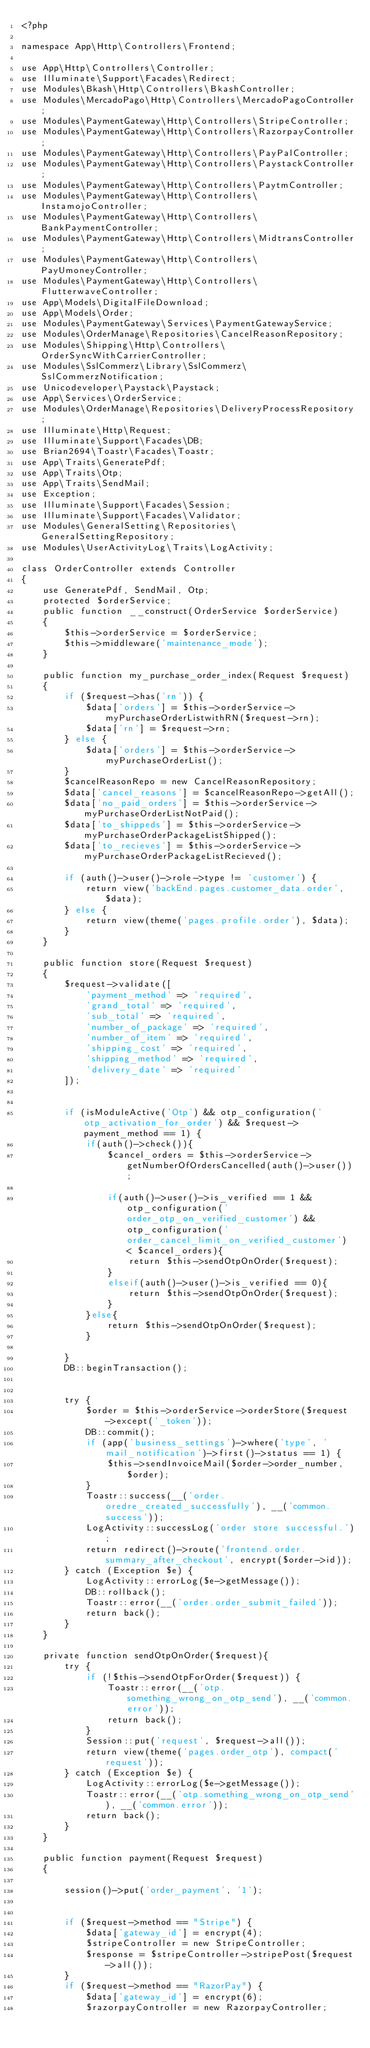<code> <loc_0><loc_0><loc_500><loc_500><_PHP_><?php

namespace App\Http\Controllers\Frontend;

use App\Http\Controllers\Controller;
use Illuminate\Support\Facades\Redirect;
use Modules\Bkash\Http\Controllers\BkashController;
use Modules\MercadoPago\Http\Controllers\MercadoPagoController;
use Modules\PaymentGateway\Http\Controllers\StripeController;
use Modules\PaymentGateway\Http\Controllers\RazorpayController;
use Modules\PaymentGateway\Http\Controllers\PayPalController;
use Modules\PaymentGateway\Http\Controllers\PaystackController;
use Modules\PaymentGateway\Http\Controllers\PaytmController;
use Modules\PaymentGateway\Http\Controllers\InstamojoController;
use Modules\PaymentGateway\Http\Controllers\BankPaymentController;
use Modules\PaymentGateway\Http\Controllers\MidtransController;
use Modules\PaymentGateway\Http\Controllers\PayUmoneyController;
use Modules\PaymentGateway\Http\Controllers\FlutterwaveController;
use App\Models\DigitalFileDownload;
use App\Models\Order;
use Modules\PaymentGateway\Services\PaymentGatewayService;
use Modules\OrderManage\Repositories\CancelReasonRepository;
use Modules\Shipping\Http\Controllers\OrderSyncWithCarrierController;
use Modules\SslCommerz\Library\SslCommerz\SslCommerzNotification;
use Unicodeveloper\Paystack\Paystack;
use App\Services\OrderService;
use Modules\OrderManage\Repositories\DeliveryProcessRepository;
use Illuminate\Http\Request;
use Illuminate\Support\Facades\DB;
use Brian2694\Toastr\Facades\Toastr;
use App\Traits\GeneratePdf;
use App\Traits\Otp;
use App\Traits\SendMail;
use Exception;
use Illuminate\Support\Facades\Session;
use Illuminate\Support\Facades\Validator;
use Modules\GeneralSetting\Repositories\GeneralSettingRepository;
use Modules\UserActivityLog\Traits\LogActivity;

class OrderController extends Controller
{
    use GeneratePdf, SendMail, Otp;
    protected $orderService;
    public function __construct(OrderService $orderService)
    {
        $this->orderService = $orderService;
        $this->middleware('maintenance_mode');
    }

    public function my_purchase_order_index(Request $request)
    {
        if ($request->has('rn')) {
            $data['orders'] = $this->orderService->myPurchaseOrderListwithRN($request->rn);
            $data['rn'] = $request->rn;
        } else {
            $data['orders'] = $this->orderService->myPurchaseOrderList();
        }
        $cancelReasonRepo = new CancelReasonRepository;
        $data['cancel_reasons'] = $cancelReasonRepo->getAll();
        $data['no_paid_orders'] = $this->orderService->myPurchaseOrderListNotPaid();
        $data['to_shippeds'] = $this->orderService->myPurchaseOrderPackageListShipped();
        $data['to_recieves'] = $this->orderService->myPurchaseOrderPackageListRecieved();

        if (auth()->user()->role->type != 'customer') {
            return view('backEnd.pages.customer_data.order', $data);
        } else {
            return view(theme('pages.profile.order'), $data);
        }
    }

    public function store(Request $request)
    {
        $request->validate([
            'payment_method' => 'required',
            'grand_total' => 'required',
            'sub_total' => 'required',
            'number_of_package' => 'required',
            'number_of_item' => 'required',
            'shipping_cost' => 'required',
            'shipping_method' => 'required',
            'delivery_date' => 'required'
        ]);


        if (isModuleActive('Otp') && otp_configuration('otp_activation_for_order') && $request->payment_method == 1) {
            if(auth()->check()){
                $cancel_orders = $this->orderService->getNumberOfOrdersCancelled(auth()->user());

                if(auth()->user()->is_verified == 1 && otp_configuration('order_otp_on_verified_customer') && otp_configuration('order_cancel_limit_on_verified_customer') < $cancel_orders){
                    return $this->sendOtpOnOrder($request);
                }
                elseif(auth()->user()->is_verified == 0){
                    return $this->sendOtpOnOrder($request);
                }
            }else{
                return $this->sendOtpOnOrder($request);
            }

        }
        DB::beginTransaction();


        try {
            $order = $this->orderService->orderStore($request->except('_token'));
            DB::commit();
            if (app('business_settings')->where('type', 'mail_notification')->first()->status == 1) {
                $this->sendInvoiceMail($order->order_number, $order);
            }
            Toastr::success(__('order.oredre_created_successfully'), __('common.success'));
            LogActivity::successLog('order store successful.');
            return redirect()->route('frontend.order.summary_after_checkout', encrypt($order->id));
        } catch (Exception $e) {
            LogActivity::errorLog($e->getMessage());
            DB::rollback();
            Toastr::error(__('order.order_submit_failed'));
            return back();
        }
    }

    private function sendOtpOnOrder($request){
        try {
            if (!$this->sendOtpForOrder($request)) {
                Toastr::error(__('otp.something_wrong_on_otp_send'), __('common.error'));
                return back();
            }
            Session::put('request', $request->all());
            return view(theme('pages.order_otp'), compact('request'));
        } catch (Exception $e) {
            LogActivity::errorLog($e->getMessage());
            Toastr::error(__('otp.something_wrong_on_otp_send'), __('common.error'));
            return back();
        }
    }

    public function payment(Request $request)
    {

        session()->put('order_payment', '1');


        if ($request->method == "Stripe") {
            $data['gateway_id'] = encrypt(4);
            $stripeController = new StripeController;
            $response = $stripeController->stripePost($request->all());
        }
        if ($request->method == "RazorPay") {
            $data['gateway_id'] = encrypt(6);
            $razorpayController = new RazorpayController;</code> 